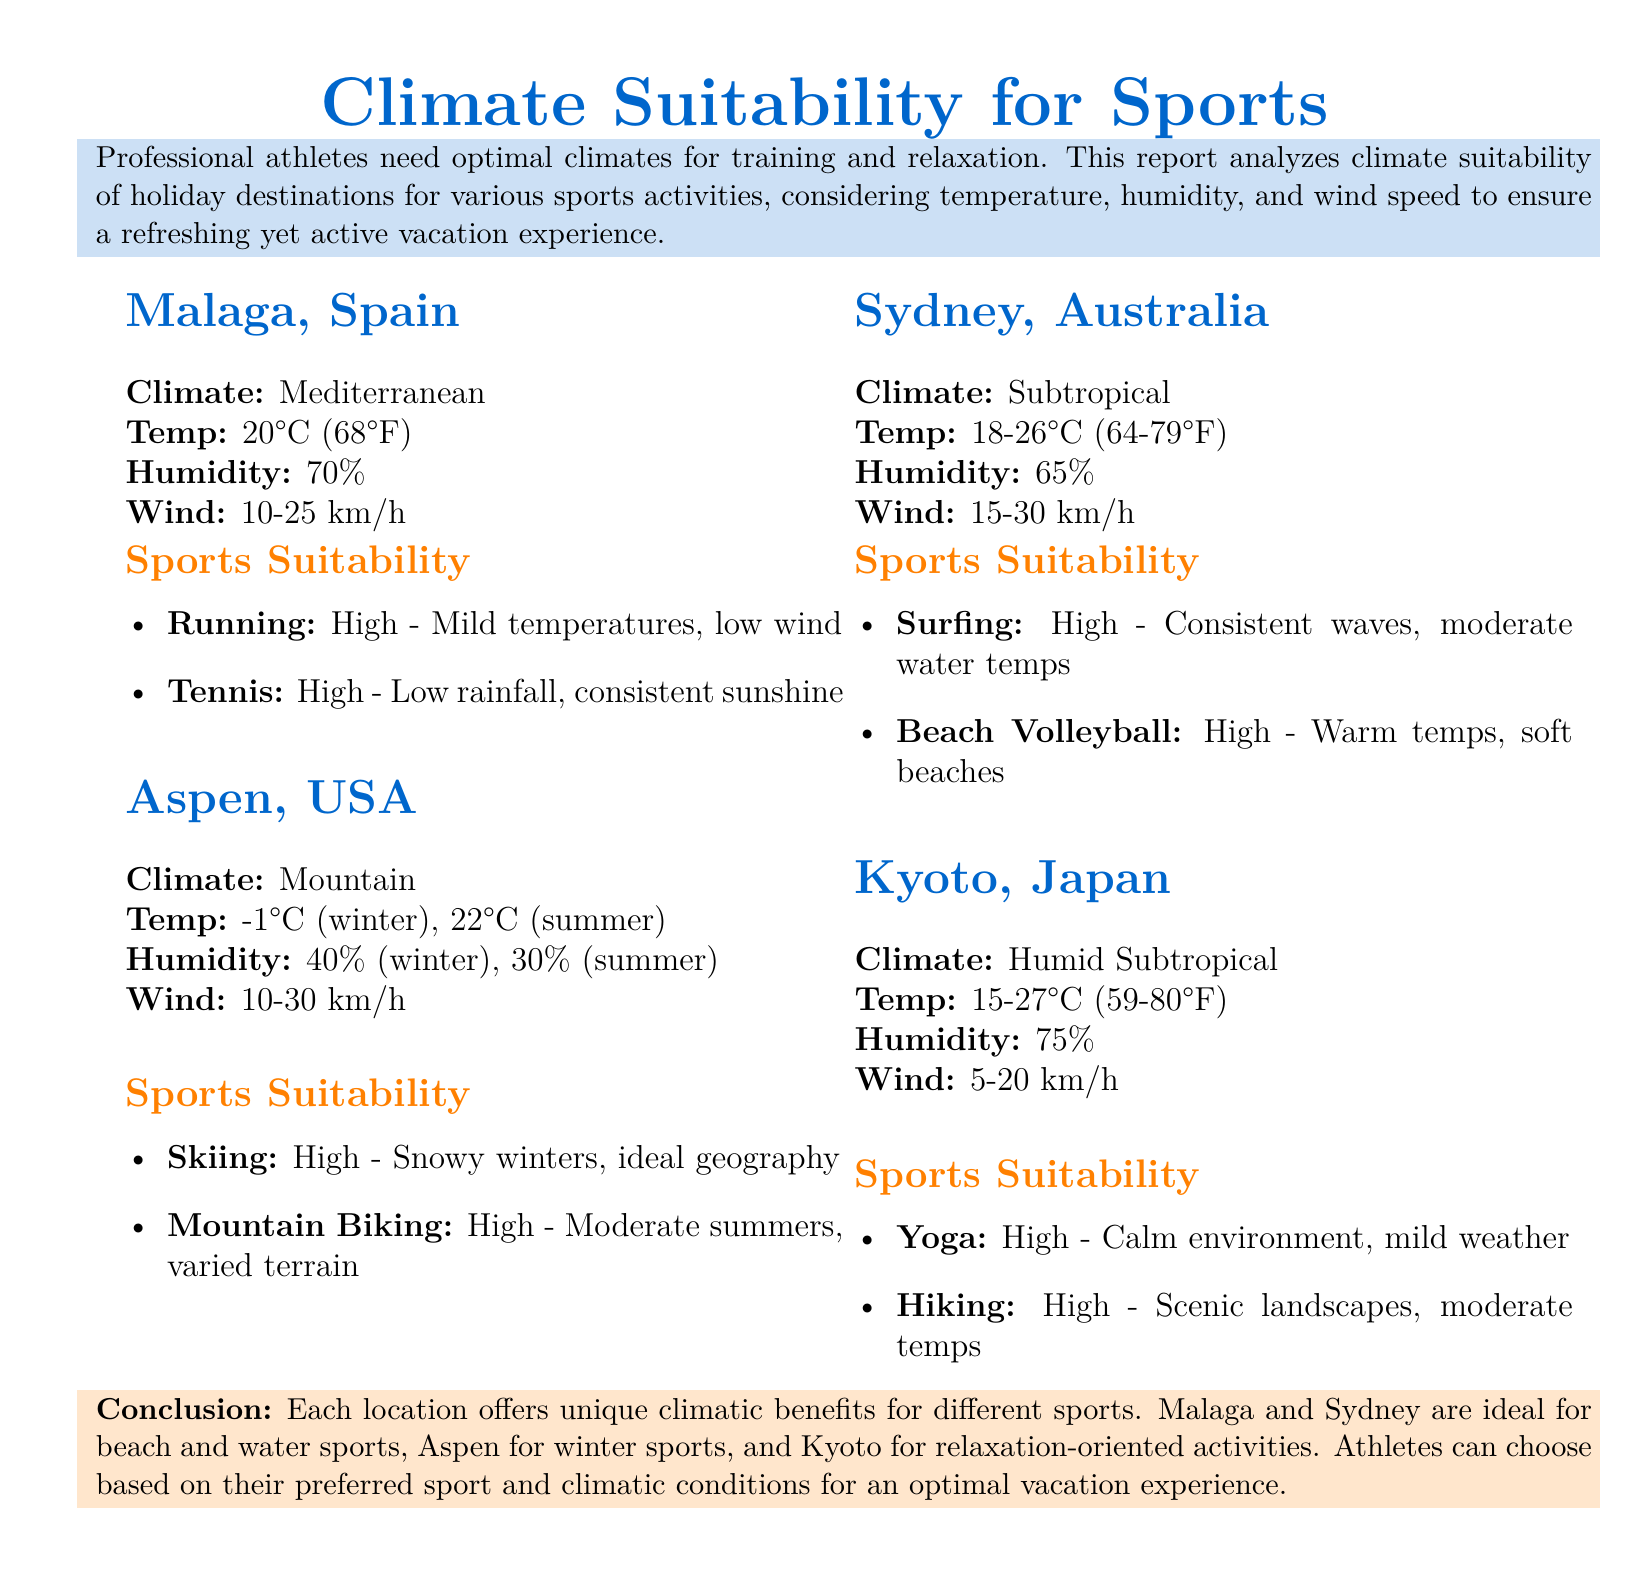What is the temperature range in Sydney? The temperature range in Sydney is specified as 18-26°C (64-79°F).
Answer: 18-26°C (64-79°F) Which sport is noted as highly suitable in Malaga? The document states that "Running" is highly suitable in Malaga due to mild temperatures and low wind.
Answer: Running What is the humidity percentage in Aspen during winter? The report indicates that Aspen's humidity is 40% during winter.
Answer: 40% How suitable is surfing in Sydney? The document mentions that surfing has a "High" suitability rating in Sydney, thanks to consistent waves.
Answer: High What climatic type is associated with Kyoto? Kyoto is classified under "Humid Subtropical" climate according to the document.
Answer: Humid Subtropical Which location offers optimal conditions for Yoga? The document specifies that "Kyoto, Japan" is ideal for Yoga due to its calm environment and mild weather.
Answer: Kyoto, Japan What is the wind speed range in Malaga? The wind speed in Malaga ranges from 10-25 km/h as stated in the document.
Answer: 10-25 km/h What sport is associated with Aspen's summer climate? The document highlights "Mountain Biking" as highly suitable during Aspen's summer climate.
Answer: Mountain Biking What is the conclusion regarding Malaga's climate for sports? It states that Malaga is ideal for beach and water sports, emphasizing its climatic benefits.
Answer: Ideal for beach and water sports 